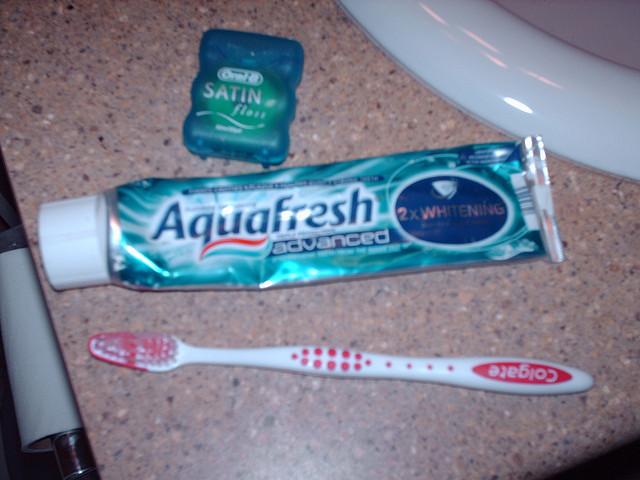What colors are the toothbrush?
Answer briefly. White and pink. How many manual toothbrushes?
Answer briefly. 1. How many brushes do you see?
Answer briefly. 1. How much toilet paper is on the roll?
Quick response, please. Very little. What kind of toothpaste?
Be succinct. Aquafresh. Are the bristles turned upward?
Keep it brief. Yes. What brand of toothpaste is this?
Keep it brief. Aquafresh. How many toothbrushes are there?
Short answer required. 1. What brand or toothbrush is pictured?
Answer briefly. Colgate. 